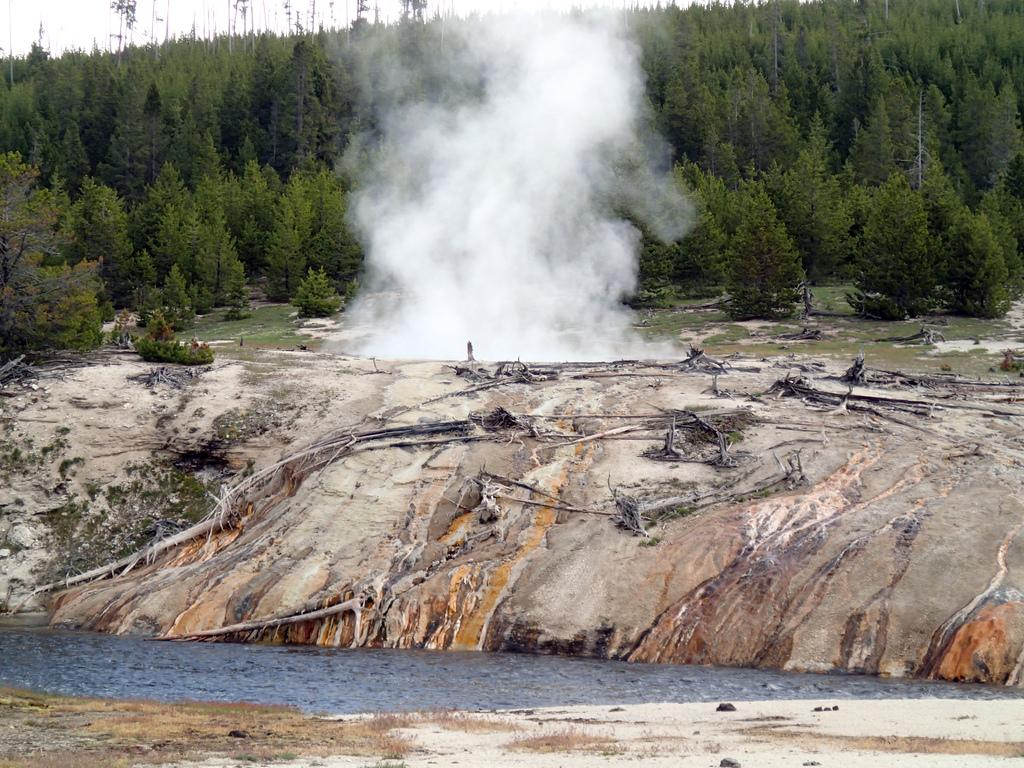What type of smoke can be seen in the image? There is white color smoke in the image. What natural elements are present in the image? There are trees and water visible in the image. What can be seen in the background of the image? The sky is visible in the background of the image. What is the purpose of the porter in the image? There is no porter present in the image, so it is not possible to determine its purpose. 